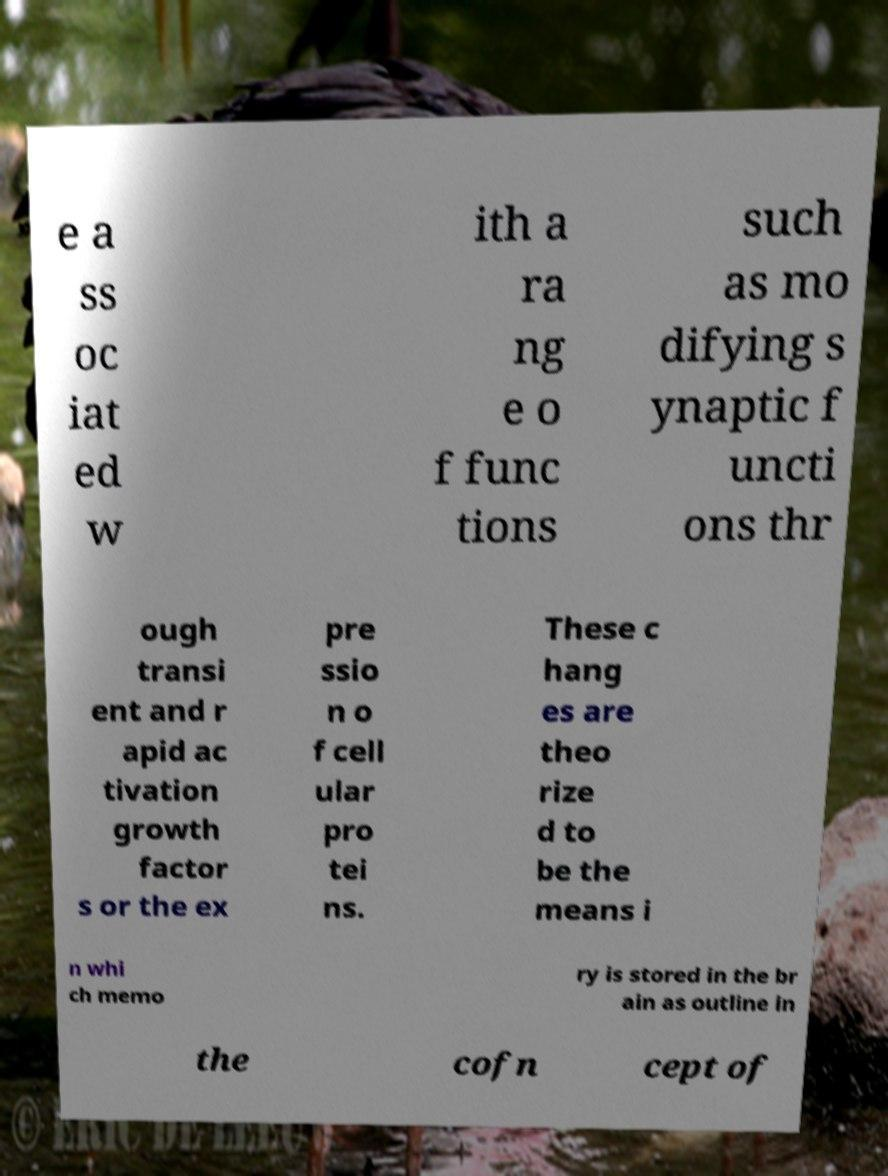What messages or text are displayed in this image? I need them in a readable, typed format. The text in the image reads: '...associated with a range of functions such as modifying synaptic functions through transient and rapid activation growth factors or the expression of cellular proteins. These changes are theorized to be the means in which memory is stored in the brain as outlined in the concept of...' 